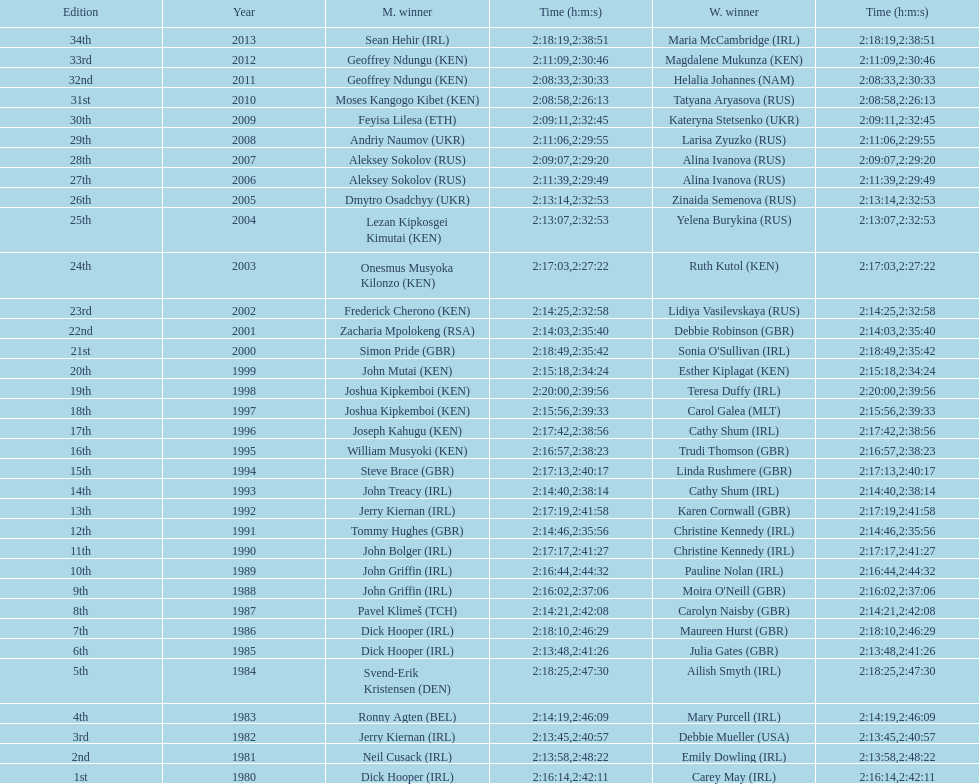Parse the full table. {'header': ['Edition', 'Year', 'M. winner', 'Time (h:m:s)', 'W. winner', 'Time (h:m:s)'], 'rows': [['34th', '2013', 'Sean Hehir\xa0(IRL)', '2:18:19', 'Maria McCambridge\xa0(IRL)', '2:38:51'], ['33rd', '2012', 'Geoffrey Ndungu\xa0(KEN)', '2:11:09', 'Magdalene Mukunza\xa0(KEN)', '2:30:46'], ['32nd', '2011', 'Geoffrey Ndungu\xa0(KEN)', '2:08:33', 'Helalia Johannes\xa0(NAM)', '2:30:33'], ['31st', '2010', 'Moses Kangogo Kibet\xa0(KEN)', '2:08:58', 'Tatyana Aryasova\xa0(RUS)', '2:26:13'], ['30th', '2009', 'Feyisa Lilesa\xa0(ETH)', '2:09:11', 'Kateryna Stetsenko\xa0(UKR)', '2:32:45'], ['29th', '2008', 'Andriy Naumov\xa0(UKR)', '2:11:06', 'Larisa Zyuzko\xa0(RUS)', '2:29:55'], ['28th', '2007', 'Aleksey Sokolov\xa0(RUS)', '2:09:07', 'Alina Ivanova\xa0(RUS)', '2:29:20'], ['27th', '2006', 'Aleksey Sokolov\xa0(RUS)', '2:11:39', 'Alina Ivanova\xa0(RUS)', '2:29:49'], ['26th', '2005', 'Dmytro Osadchyy\xa0(UKR)', '2:13:14', 'Zinaida Semenova\xa0(RUS)', '2:32:53'], ['25th', '2004', 'Lezan Kipkosgei Kimutai\xa0(KEN)', '2:13:07', 'Yelena Burykina\xa0(RUS)', '2:32:53'], ['24th', '2003', 'Onesmus Musyoka Kilonzo\xa0(KEN)', '2:17:03', 'Ruth Kutol\xa0(KEN)', '2:27:22'], ['23rd', '2002', 'Frederick Cherono\xa0(KEN)', '2:14:25', 'Lidiya Vasilevskaya\xa0(RUS)', '2:32:58'], ['22nd', '2001', 'Zacharia Mpolokeng\xa0(RSA)', '2:14:03', 'Debbie Robinson\xa0(GBR)', '2:35:40'], ['21st', '2000', 'Simon Pride\xa0(GBR)', '2:18:49', "Sonia O'Sullivan\xa0(IRL)", '2:35:42'], ['20th', '1999', 'John Mutai\xa0(KEN)', '2:15:18', 'Esther Kiplagat\xa0(KEN)', '2:34:24'], ['19th', '1998', 'Joshua Kipkemboi\xa0(KEN)', '2:20:00', 'Teresa Duffy\xa0(IRL)', '2:39:56'], ['18th', '1997', 'Joshua Kipkemboi\xa0(KEN)', '2:15:56', 'Carol Galea\xa0(MLT)', '2:39:33'], ['17th', '1996', 'Joseph Kahugu\xa0(KEN)', '2:17:42', 'Cathy Shum\xa0(IRL)', '2:38:56'], ['16th', '1995', 'William Musyoki\xa0(KEN)', '2:16:57', 'Trudi Thomson\xa0(GBR)', '2:38:23'], ['15th', '1994', 'Steve Brace\xa0(GBR)', '2:17:13', 'Linda Rushmere\xa0(GBR)', '2:40:17'], ['14th', '1993', 'John Treacy\xa0(IRL)', '2:14:40', 'Cathy Shum\xa0(IRL)', '2:38:14'], ['13th', '1992', 'Jerry Kiernan\xa0(IRL)', '2:17:19', 'Karen Cornwall\xa0(GBR)', '2:41:58'], ['12th', '1991', 'Tommy Hughes\xa0(GBR)', '2:14:46', 'Christine Kennedy\xa0(IRL)', '2:35:56'], ['11th', '1990', 'John Bolger\xa0(IRL)', '2:17:17', 'Christine Kennedy\xa0(IRL)', '2:41:27'], ['10th', '1989', 'John Griffin\xa0(IRL)', '2:16:44', 'Pauline Nolan\xa0(IRL)', '2:44:32'], ['9th', '1988', 'John Griffin\xa0(IRL)', '2:16:02', "Moira O'Neill\xa0(GBR)", '2:37:06'], ['8th', '1987', 'Pavel Klimeš\xa0(TCH)', '2:14:21', 'Carolyn Naisby\xa0(GBR)', '2:42:08'], ['7th', '1986', 'Dick Hooper\xa0(IRL)', '2:18:10', 'Maureen Hurst\xa0(GBR)', '2:46:29'], ['6th', '1985', 'Dick Hooper\xa0(IRL)', '2:13:48', 'Julia Gates\xa0(GBR)', '2:41:26'], ['5th', '1984', 'Svend-Erik Kristensen\xa0(DEN)', '2:18:25', 'Ailish Smyth\xa0(IRL)', '2:47:30'], ['4th', '1983', 'Ronny Agten\xa0(BEL)', '2:14:19', 'Mary Purcell\xa0(IRL)', '2:46:09'], ['3rd', '1982', 'Jerry Kiernan\xa0(IRL)', '2:13:45', 'Debbie Mueller\xa0(USA)', '2:40:57'], ['2nd', '1981', 'Neil Cusack\xa0(IRL)', '2:13:58', 'Emily Dowling\xa0(IRL)', '2:48:22'], ['1st', '1980', 'Dick Hooper\xa0(IRL)', '2:16:14', 'Carey May\xa0(IRL)', '2:42:11']]} Who won after joseph kipkemboi's winning streak ended? John Mutai (KEN). 